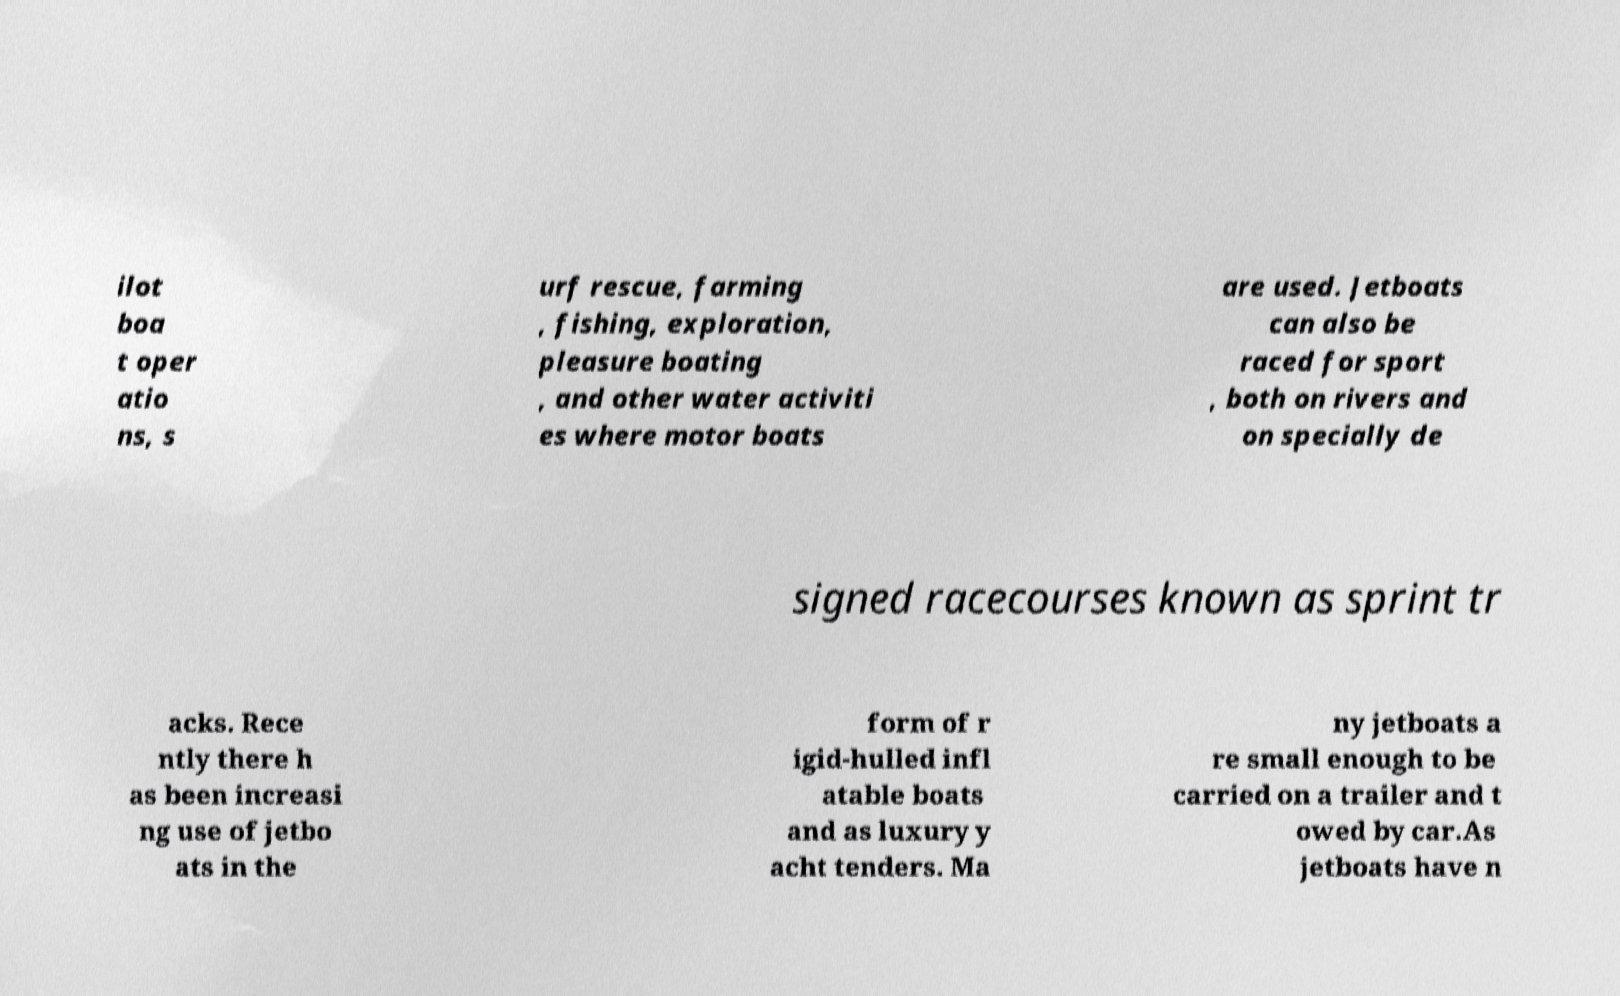There's text embedded in this image that I need extracted. Can you transcribe it verbatim? ilot boa t oper atio ns, s urf rescue, farming , fishing, exploration, pleasure boating , and other water activiti es where motor boats are used. Jetboats can also be raced for sport , both on rivers and on specially de signed racecourses known as sprint tr acks. Rece ntly there h as been increasi ng use of jetbo ats in the form of r igid-hulled infl atable boats and as luxury y acht tenders. Ma ny jetboats a re small enough to be carried on a trailer and t owed by car.As jetboats have n 